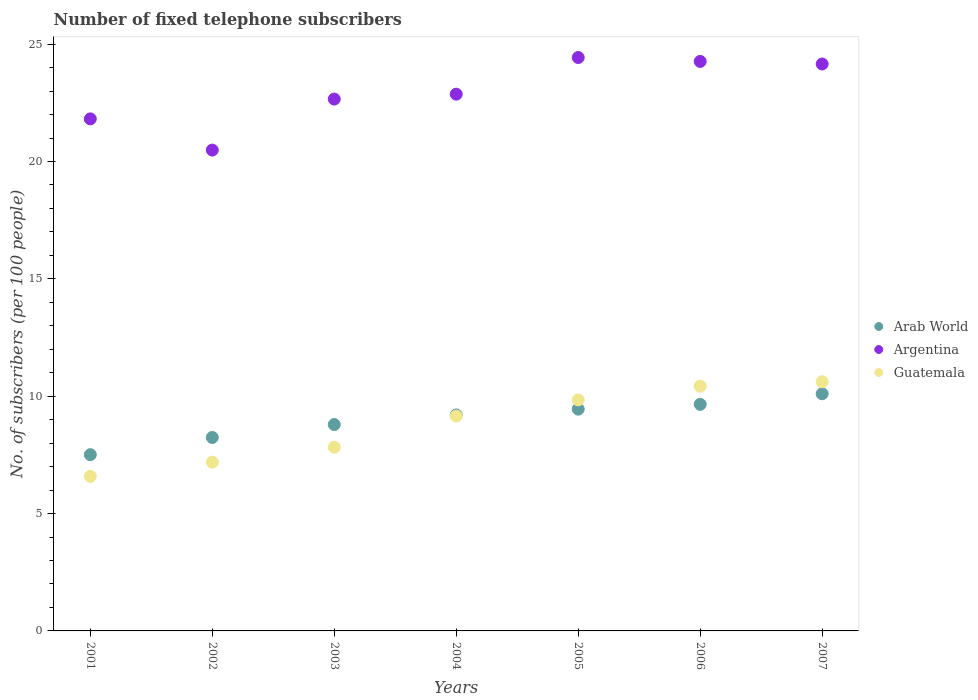What is the number of fixed telephone subscribers in Argentina in 2004?
Provide a short and direct response. 22.87. Across all years, what is the maximum number of fixed telephone subscribers in Argentina?
Make the answer very short. 24.43. Across all years, what is the minimum number of fixed telephone subscribers in Guatemala?
Your response must be concise. 6.59. In which year was the number of fixed telephone subscribers in Arab World maximum?
Your response must be concise. 2007. What is the total number of fixed telephone subscribers in Guatemala in the graph?
Ensure brevity in your answer.  61.64. What is the difference between the number of fixed telephone subscribers in Arab World in 2003 and that in 2006?
Make the answer very short. -0.86. What is the difference between the number of fixed telephone subscribers in Guatemala in 2006 and the number of fixed telephone subscribers in Arab World in 2002?
Your answer should be compact. 2.18. What is the average number of fixed telephone subscribers in Argentina per year?
Keep it short and to the point. 22.95. In the year 2001, what is the difference between the number of fixed telephone subscribers in Arab World and number of fixed telephone subscribers in Guatemala?
Your response must be concise. 0.92. What is the ratio of the number of fixed telephone subscribers in Arab World in 2005 to that in 2006?
Keep it short and to the point. 0.98. Is the number of fixed telephone subscribers in Guatemala in 2002 less than that in 2007?
Offer a terse response. Yes. What is the difference between the highest and the second highest number of fixed telephone subscribers in Guatemala?
Your answer should be very brief. 0.19. What is the difference between the highest and the lowest number of fixed telephone subscribers in Arab World?
Give a very brief answer. 2.6. Is the number of fixed telephone subscribers in Arab World strictly greater than the number of fixed telephone subscribers in Guatemala over the years?
Your response must be concise. No. What is the difference between two consecutive major ticks on the Y-axis?
Offer a very short reply. 5. Are the values on the major ticks of Y-axis written in scientific E-notation?
Offer a terse response. No. Does the graph contain any zero values?
Your answer should be very brief. No. Where does the legend appear in the graph?
Make the answer very short. Center right. How are the legend labels stacked?
Your response must be concise. Vertical. What is the title of the graph?
Your answer should be compact. Number of fixed telephone subscribers. What is the label or title of the X-axis?
Your answer should be very brief. Years. What is the label or title of the Y-axis?
Offer a very short reply. No. of subscribers (per 100 people). What is the No. of subscribers (per 100 people) in Arab World in 2001?
Ensure brevity in your answer.  7.51. What is the No. of subscribers (per 100 people) in Argentina in 2001?
Make the answer very short. 21.82. What is the No. of subscribers (per 100 people) of Guatemala in 2001?
Give a very brief answer. 6.59. What is the No. of subscribers (per 100 people) of Arab World in 2002?
Your answer should be very brief. 8.24. What is the No. of subscribers (per 100 people) in Argentina in 2002?
Provide a short and direct response. 20.49. What is the No. of subscribers (per 100 people) in Guatemala in 2002?
Offer a very short reply. 7.19. What is the No. of subscribers (per 100 people) of Arab World in 2003?
Provide a succinct answer. 8.79. What is the No. of subscribers (per 100 people) in Argentina in 2003?
Give a very brief answer. 22.66. What is the No. of subscribers (per 100 people) of Guatemala in 2003?
Offer a very short reply. 7.83. What is the No. of subscribers (per 100 people) of Arab World in 2004?
Provide a short and direct response. 9.2. What is the No. of subscribers (per 100 people) of Argentina in 2004?
Offer a very short reply. 22.87. What is the No. of subscribers (per 100 people) in Guatemala in 2004?
Offer a terse response. 9.15. What is the No. of subscribers (per 100 people) in Arab World in 2005?
Give a very brief answer. 9.45. What is the No. of subscribers (per 100 people) in Argentina in 2005?
Your answer should be compact. 24.43. What is the No. of subscribers (per 100 people) in Guatemala in 2005?
Ensure brevity in your answer.  9.84. What is the No. of subscribers (per 100 people) of Arab World in 2006?
Provide a short and direct response. 9.65. What is the No. of subscribers (per 100 people) in Argentina in 2006?
Your answer should be very brief. 24.26. What is the No. of subscribers (per 100 people) of Guatemala in 2006?
Provide a short and direct response. 10.43. What is the No. of subscribers (per 100 people) in Arab World in 2007?
Your answer should be compact. 10.1. What is the No. of subscribers (per 100 people) of Argentina in 2007?
Your answer should be compact. 24.15. What is the No. of subscribers (per 100 people) in Guatemala in 2007?
Provide a short and direct response. 10.61. Across all years, what is the maximum No. of subscribers (per 100 people) in Arab World?
Offer a terse response. 10.1. Across all years, what is the maximum No. of subscribers (per 100 people) of Argentina?
Give a very brief answer. 24.43. Across all years, what is the maximum No. of subscribers (per 100 people) in Guatemala?
Provide a short and direct response. 10.61. Across all years, what is the minimum No. of subscribers (per 100 people) of Arab World?
Make the answer very short. 7.51. Across all years, what is the minimum No. of subscribers (per 100 people) of Argentina?
Your answer should be very brief. 20.49. Across all years, what is the minimum No. of subscribers (per 100 people) of Guatemala?
Provide a short and direct response. 6.59. What is the total No. of subscribers (per 100 people) of Arab World in the graph?
Your answer should be very brief. 62.95. What is the total No. of subscribers (per 100 people) of Argentina in the graph?
Offer a terse response. 160.68. What is the total No. of subscribers (per 100 people) of Guatemala in the graph?
Keep it short and to the point. 61.64. What is the difference between the No. of subscribers (per 100 people) in Arab World in 2001 and that in 2002?
Keep it short and to the point. -0.73. What is the difference between the No. of subscribers (per 100 people) in Argentina in 2001 and that in 2002?
Make the answer very short. 1.33. What is the difference between the No. of subscribers (per 100 people) of Guatemala in 2001 and that in 2002?
Provide a succinct answer. -0.6. What is the difference between the No. of subscribers (per 100 people) of Arab World in 2001 and that in 2003?
Give a very brief answer. -1.28. What is the difference between the No. of subscribers (per 100 people) in Argentina in 2001 and that in 2003?
Offer a very short reply. -0.84. What is the difference between the No. of subscribers (per 100 people) in Guatemala in 2001 and that in 2003?
Give a very brief answer. -1.24. What is the difference between the No. of subscribers (per 100 people) in Arab World in 2001 and that in 2004?
Make the answer very short. -1.69. What is the difference between the No. of subscribers (per 100 people) of Argentina in 2001 and that in 2004?
Ensure brevity in your answer.  -1.05. What is the difference between the No. of subscribers (per 100 people) in Guatemala in 2001 and that in 2004?
Make the answer very short. -2.57. What is the difference between the No. of subscribers (per 100 people) in Arab World in 2001 and that in 2005?
Provide a succinct answer. -1.94. What is the difference between the No. of subscribers (per 100 people) of Argentina in 2001 and that in 2005?
Provide a succinct answer. -2.61. What is the difference between the No. of subscribers (per 100 people) of Guatemala in 2001 and that in 2005?
Ensure brevity in your answer.  -3.26. What is the difference between the No. of subscribers (per 100 people) in Arab World in 2001 and that in 2006?
Give a very brief answer. -2.14. What is the difference between the No. of subscribers (per 100 people) in Argentina in 2001 and that in 2006?
Provide a short and direct response. -2.45. What is the difference between the No. of subscribers (per 100 people) in Guatemala in 2001 and that in 2006?
Give a very brief answer. -3.84. What is the difference between the No. of subscribers (per 100 people) in Arab World in 2001 and that in 2007?
Make the answer very short. -2.6. What is the difference between the No. of subscribers (per 100 people) in Argentina in 2001 and that in 2007?
Offer a terse response. -2.34. What is the difference between the No. of subscribers (per 100 people) in Guatemala in 2001 and that in 2007?
Ensure brevity in your answer.  -4.03. What is the difference between the No. of subscribers (per 100 people) in Arab World in 2002 and that in 2003?
Your response must be concise. -0.55. What is the difference between the No. of subscribers (per 100 people) in Argentina in 2002 and that in 2003?
Ensure brevity in your answer.  -2.17. What is the difference between the No. of subscribers (per 100 people) of Guatemala in 2002 and that in 2003?
Your answer should be compact. -0.64. What is the difference between the No. of subscribers (per 100 people) of Arab World in 2002 and that in 2004?
Your answer should be very brief. -0.96. What is the difference between the No. of subscribers (per 100 people) in Argentina in 2002 and that in 2004?
Your answer should be compact. -2.38. What is the difference between the No. of subscribers (per 100 people) in Guatemala in 2002 and that in 2004?
Keep it short and to the point. -1.96. What is the difference between the No. of subscribers (per 100 people) in Arab World in 2002 and that in 2005?
Your answer should be very brief. -1.21. What is the difference between the No. of subscribers (per 100 people) in Argentina in 2002 and that in 2005?
Ensure brevity in your answer.  -3.94. What is the difference between the No. of subscribers (per 100 people) of Guatemala in 2002 and that in 2005?
Ensure brevity in your answer.  -2.65. What is the difference between the No. of subscribers (per 100 people) of Arab World in 2002 and that in 2006?
Give a very brief answer. -1.41. What is the difference between the No. of subscribers (per 100 people) in Argentina in 2002 and that in 2006?
Ensure brevity in your answer.  -3.78. What is the difference between the No. of subscribers (per 100 people) of Guatemala in 2002 and that in 2006?
Ensure brevity in your answer.  -3.24. What is the difference between the No. of subscribers (per 100 people) in Arab World in 2002 and that in 2007?
Provide a succinct answer. -1.86. What is the difference between the No. of subscribers (per 100 people) in Argentina in 2002 and that in 2007?
Make the answer very short. -3.67. What is the difference between the No. of subscribers (per 100 people) in Guatemala in 2002 and that in 2007?
Ensure brevity in your answer.  -3.42. What is the difference between the No. of subscribers (per 100 people) in Arab World in 2003 and that in 2004?
Keep it short and to the point. -0.41. What is the difference between the No. of subscribers (per 100 people) in Argentina in 2003 and that in 2004?
Make the answer very short. -0.21. What is the difference between the No. of subscribers (per 100 people) of Guatemala in 2003 and that in 2004?
Provide a succinct answer. -1.33. What is the difference between the No. of subscribers (per 100 people) of Arab World in 2003 and that in 2005?
Offer a terse response. -0.65. What is the difference between the No. of subscribers (per 100 people) in Argentina in 2003 and that in 2005?
Your answer should be very brief. -1.77. What is the difference between the No. of subscribers (per 100 people) in Guatemala in 2003 and that in 2005?
Offer a terse response. -2.02. What is the difference between the No. of subscribers (per 100 people) in Arab World in 2003 and that in 2006?
Give a very brief answer. -0.86. What is the difference between the No. of subscribers (per 100 people) in Argentina in 2003 and that in 2006?
Your answer should be compact. -1.6. What is the difference between the No. of subscribers (per 100 people) in Guatemala in 2003 and that in 2006?
Provide a short and direct response. -2.6. What is the difference between the No. of subscribers (per 100 people) of Arab World in 2003 and that in 2007?
Provide a short and direct response. -1.31. What is the difference between the No. of subscribers (per 100 people) in Argentina in 2003 and that in 2007?
Offer a terse response. -1.49. What is the difference between the No. of subscribers (per 100 people) of Guatemala in 2003 and that in 2007?
Offer a terse response. -2.79. What is the difference between the No. of subscribers (per 100 people) in Arab World in 2004 and that in 2005?
Your response must be concise. -0.25. What is the difference between the No. of subscribers (per 100 people) in Argentina in 2004 and that in 2005?
Keep it short and to the point. -1.56. What is the difference between the No. of subscribers (per 100 people) of Guatemala in 2004 and that in 2005?
Your response must be concise. -0.69. What is the difference between the No. of subscribers (per 100 people) of Arab World in 2004 and that in 2006?
Your response must be concise. -0.45. What is the difference between the No. of subscribers (per 100 people) in Argentina in 2004 and that in 2006?
Provide a short and direct response. -1.39. What is the difference between the No. of subscribers (per 100 people) in Guatemala in 2004 and that in 2006?
Offer a terse response. -1.27. What is the difference between the No. of subscribers (per 100 people) of Arab World in 2004 and that in 2007?
Your response must be concise. -0.9. What is the difference between the No. of subscribers (per 100 people) of Argentina in 2004 and that in 2007?
Make the answer very short. -1.29. What is the difference between the No. of subscribers (per 100 people) of Guatemala in 2004 and that in 2007?
Keep it short and to the point. -1.46. What is the difference between the No. of subscribers (per 100 people) of Arab World in 2005 and that in 2006?
Your response must be concise. -0.21. What is the difference between the No. of subscribers (per 100 people) of Argentina in 2005 and that in 2006?
Make the answer very short. 0.17. What is the difference between the No. of subscribers (per 100 people) in Guatemala in 2005 and that in 2006?
Keep it short and to the point. -0.58. What is the difference between the No. of subscribers (per 100 people) in Arab World in 2005 and that in 2007?
Your answer should be compact. -0.66. What is the difference between the No. of subscribers (per 100 people) in Argentina in 2005 and that in 2007?
Make the answer very short. 0.28. What is the difference between the No. of subscribers (per 100 people) in Guatemala in 2005 and that in 2007?
Provide a short and direct response. -0.77. What is the difference between the No. of subscribers (per 100 people) of Arab World in 2006 and that in 2007?
Keep it short and to the point. -0.45. What is the difference between the No. of subscribers (per 100 people) in Argentina in 2006 and that in 2007?
Offer a terse response. 0.11. What is the difference between the No. of subscribers (per 100 people) of Guatemala in 2006 and that in 2007?
Your answer should be very brief. -0.19. What is the difference between the No. of subscribers (per 100 people) of Arab World in 2001 and the No. of subscribers (per 100 people) of Argentina in 2002?
Ensure brevity in your answer.  -12.98. What is the difference between the No. of subscribers (per 100 people) of Arab World in 2001 and the No. of subscribers (per 100 people) of Guatemala in 2002?
Provide a short and direct response. 0.32. What is the difference between the No. of subscribers (per 100 people) of Argentina in 2001 and the No. of subscribers (per 100 people) of Guatemala in 2002?
Your answer should be compact. 14.63. What is the difference between the No. of subscribers (per 100 people) in Arab World in 2001 and the No. of subscribers (per 100 people) in Argentina in 2003?
Your answer should be very brief. -15.15. What is the difference between the No. of subscribers (per 100 people) of Arab World in 2001 and the No. of subscribers (per 100 people) of Guatemala in 2003?
Offer a terse response. -0.32. What is the difference between the No. of subscribers (per 100 people) of Argentina in 2001 and the No. of subscribers (per 100 people) of Guatemala in 2003?
Offer a very short reply. 13.99. What is the difference between the No. of subscribers (per 100 people) of Arab World in 2001 and the No. of subscribers (per 100 people) of Argentina in 2004?
Your answer should be very brief. -15.36. What is the difference between the No. of subscribers (per 100 people) of Arab World in 2001 and the No. of subscribers (per 100 people) of Guatemala in 2004?
Keep it short and to the point. -1.64. What is the difference between the No. of subscribers (per 100 people) of Argentina in 2001 and the No. of subscribers (per 100 people) of Guatemala in 2004?
Offer a terse response. 12.66. What is the difference between the No. of subscribers (per 100 people) in Arab World in 2001 and the No. of subscribers (per 100 people) in Argentina in 2005?
Offer a very short reply. -16.92. What is the difference between the No. of subscribers (per 100 people) of Arab World in 2001 and the No. of subscribers (per 100 people) of Guatemala in 2005?
Keep it short and to the point. -2.34. What is the difference between the No. of subscribers (per 100 people) in Argentina in 2001 and the No. of subscribers (per 100 people) in Guatemala in 2005?
Provide a succinct answer. 11.97. What is the difference between the No. of subscribers (per 100 people) in Arab World in 2001 and the No. of subscribers (per 100 people) in Argentina in 2006?
Your response must be concise. -16.75. What is the difference between the No. of subscribers (per 100 people) in Arab World in 2001 and the No. of subscribers (per 100 people) in Guatemala in 2006?
Your answer should be compact. -2.92. What is the difference between the No. of subscribers (per 100 people) of Argentina in 2001 and the No. of subscribers (per 100 people) of Guatemala in 2006?
Your answer should be very brief. 11.39. What is the difference between the No. of subscribers (per 100 people) in Arab World in 2001 and the No. of subscribers (per 100 people) in Argentina in 2007?
Make the answer very short. -16.64. What is the difference between the No. of subscribers (per 100 people) of Arab World in 2001 and the No. of subscribers (per 100 people) of Guatemala in 2007?
Offer a very short reply. -3.11. What is the difference between the No. of subscribers (per 100 people) of Argentina in 2001 and the No. of subscribers (per 100 people) of Guatemala in 2007?
Offer a terse response. 11.2. What is the difference between the No. of subscribers (per 100 people) of Arab World in 2002 and the No. of subscribers (per 100 people) of Argentina in 2003?
Make the answer very short. -14.42. What is the difference between the No. of subscribers (per 100 people) in Arab World in 2002 and the No. of subscribers (per 100 people) in Guatemala in 2003?
Your answer should be compact. 0.42. What is the difference between the No. of subscribers (per 100 people) of Argentina in 2002 and the No. of subscribers (per 100 people) of Guatemala in 2003?
Your response must be concise. 12.66. What is the difference between the No. of subscribers (per 100 people) in Arab World in 2002 and the No. of subscribers (per 100 people) in Argentina in 2004?
Your response must be concise. -14.63. What is the difference between the No. of subscribers (per 100 people) of Arab World in 2002 and the No. of subscribers (per 100 people) of Guatemala in 2004?
Offer a terse response. -0.91. What is the difference between the No. of subscribers (per 100 people) in Argentina in 2002 and the No. of subscribers (per 100 people) in Guatemala in 2004?
Your response must be concise. 11.33. What is the difference between the No. of subscribers (per 100 people) in Arab World in 2002 and the No. of subscribers (per 100 people) in Argentina in 2005?
Provide a succinct answer. -16.19. What is the difference between the No. of subscribers (per 100 people) of Arab World in 2002 and the No. of subscribers (per 100 people) of Guatemala in 2005?
Your response must be concise. -1.6. What is the difference between the No. of subscribers (per 100 people) of Argentina in 2002 and the No. of subscribers (per 100 people) of Guatemala in 2005?
Give a very brief answer. 10.64. What is the difference between the No. of subscribers (per 100 people) in Arab World in 2002 and the No. of subscribers (per 100 people) in Argentina in 2006?
Your answer should be very brief. -16.02. What is the difference between the No. of subscribers (per 100 people) of Arab World in 2002 and the No. of subscribers (per 100 people) of Guatemala in 2006?
Offer a terse response. -2.18. What is the difference between the No. of subscribers (per 100 people) of Argentina in 2002 and the No. of subscribers (per 100 people) of Guatemala in 2006?
Provide a succinct answer. 10.06. What is the difference between the No. of subscribers (per 100 people) of Arab World in 2002 and the No. of subscribers (per 100 people) of Argentina in 2007?
Provide a succinct answer. -15.91. What is the difference between the No. of subscribers (per 100 people) in Arab World in 2002 and the No. of subscribers (per 100 people) in Guatemala in 2007?
Give a very brief answer. -2.37. What is the difference between the No. of subscribers (per 100 people) of Argentina in 2002 and the No. of subscribers (per 100 people) of Guatemala in 2007?
Your answer should be very brief. 9.87. What is the difference between the No. of subscribers (per 100 people) in Arab World in 2003 and the No. of subscribers (per 100 people) in Argentina in 2004?
Offer a very short reply. -14.07. What is the difference between the No. of subscribers (per 100 people) in Arab World in 2003 and the No. of subscribers (per 100 people) in Guatemala in 2004?
Provide a short and direct response. -0.36. What is the difference between the No. of subscribers (per 100 people) in Argentina in 2003 and the No. of subscribers (per 100 people) in Guatemala in 2004?
Make the answer very short. 13.51. What is the difference between the No. of subscribers (per 100 people) of Arab World in 2003 and the No. of subscribers (per 100 people) of Argentina in 2005?
Give a very brief answer. -15.64. What is the difference between the No. of subscribers (per 100 people) of Arab World in 2003 and the No. of subscribers (per 100 people) of Guatemala in 2005?
Your answer should be compact. -1.05. What is the difference between the No. of subscribers (per 100 people) in Argentina in 2003 and the No. of subscribers (per 100 people) in Guatemala in 2005?
Your response must be concise. 12.81. What is the difference between the No. of subscribers (per 100 people) of Arab World in 2003 and the No. of subscribers (per 100 people) of Argentina in 2006?
Your answer should be very brief. -15.47. What is the difference between the No. of subscribers (per 100 people) in Arab World in 2003 and the No. of subscribers (per 100 people) in Guatemala in 2006?
Provide a succinct answer. -1.63. What is the difference between the No. of subscribers (per 100 people) in Argentina in 2003 and the No. of subscribers (per 100 people) in Guatemala in 2006?
Your answer should be very brief. 12.23. What is the difference between the No. of subscribers (per 100 people) of Arab World in 2003 and the No. of subscribers (per 100 people) of Argentina in 2007?
Give a very brief answer. -15.36. What is the difference between the No. of subscribers (per 100 people) of Arab World in 2003 and the No. of subscribers (per 100 people) of Guatemala in 2007?
Your answer should be compact. -1.82. What is the difference between the No. of subscribers (per 100 people) of Argentina in 2003 and the No. of subscribers (per 100 people) of Guatemala in 2007?
Give a very brief answer. 12.04. What is the difference between the No. of subscribers (per 100 people) in Arab World in 2004 and the No. of subscribers (per 100 people) in Argentina in 2005?
Give a very brief answer. -15.23. What is the difference between the No. of subscribers (per 100 people) of Arab World in 2004 and the No. of subscribers (per 100 people) of Guatemala in 2005?
Make the answer very short. -0.64. What is the difference between the No. of subscribers (per 100 people) in Argentina in 2004 and the No. of subscribers (per 100 people) in Guatemala in 2005?
Ensure brevity in your answer.  13.02. What is the difference between the No. of subscribers (per 100 people) of Arab World in 2004 and the No. of subscribers (per 100 people) of Argentina in 2006?
Provide a succinct answer. -15.06. What is the difference between the No. of subscribers (per 100 people) in Arab World in 2004 and the No. of subscribers (per 100 people) in Guatemala in 2006?
Provide a short and direct response. -1.22. What is the difference between the No. of subscribers (per 100 people) in Argentina in 2004 and the No. of subscribers (per 100 people) in Guatemala in 2006?
Provide a short and direct response. 12.44. What is the difference between the No. of subscribers (per 100 people) in Arab World in 2004 and the No. of subscribers (per 100 people) in Argentina in 2007?
Provide a succinct answer. -14.95. What is the difference between the No. of subscribers (per 100 people) in Arab World in 2004 and the No. of subscribers (per 100 people) in Guatemala in 2007?
Provide a succinct answer. -1.41. What is the difference between the No. of subscribers (per 100 people) of Argentina in 2004 and the No. of subscribers (per 100 people) of Guatemala in 2007?
Provide a succinct answer. 12.25. What is the difference between the No. of subscribers (per 100 people) of Arab World in 2005 and the No. of subscribers (per 100 people) of Argentina in 2006?
Offer a very short reply. -14.81. What is the difference between the No. of subscribers (per 100 people) of Arab World in 2005 and the No. of subscribers (per 100 people) of Guatemala in 2006?
Offer a terse response. -0.98. What is the difference between the No. of subscribers (per 100 people) in Argentina in 2005 and the No. of subscribers (per 100 people) in Guatemala in 2006?
Offer a terse response. 14. What is the difference between the No. of subscribers (per 100 people) in Arab World in 2005 and the No. of subscribers (per 100 people) in Argentina in 2007?
Give a very brief answer. -14.71. What is the difference between the No. of subscribers (per 100 people) of Arab World in 2005 and the No. of subscribers (per 100 people) of Guatemala in 2007?
Ensure brevity in your answer.  -1.17. What is the difference between the No. of subscribers (per 100 people) in Argentina in 2005 and the No. of subscribers (per 100 people) in Guatemala in 2007?
Provide a succinct answer. 13.81. What is the difference between the No. of subscribers (per 100 people) in Arab World in 2006 and the No. of subscribers (per 100 people) in Argentina in 2007?
Provide a short and direct response. -14.5. What is the difference between the No. of subscribers (per 100 people) of Arab World in 2006 and the No. of subscribers (per 100 people) of Guatemala in 2007?
Give a very brief answer. -0.96. What is the difference between the No. of subscribers (per 100 people) of Argentina in 2006 and the No. of subscribers (per 100 people) of Guatemala in 2007?
Offer a terse response. 13.65. What is the average No. of subscribers (per 100 people) in Arab World per year?
Keep it short and to the point. 8.99. What is the average No. of subscribers (per 100 people) of Argentina per year?
Your response must be concise. 22.95. What is the average No. of subscribers (per 100 people) of Guatemala per year?
Your answer should be very brief. 8.81. In the year 2001, what is the difference between the No. of subscribers (per 100 people) in Arab World and No. of subscribers (per 100 people) in Argentina?
Your answer should be compact. -14.31. In the year 2001, what is the difference between the No. of subscribers (per 100 people) of Arab World and No. of subscribers (per 100 people) of Guatemala?
Your answer should be very brief. 0.92. In the year 2001, what is the difference between the No. of subscribers (per 100 people) in Argentina and No. of subscribers (per 100 people) in Guatemala?
Offer a terse response. 15.23. In the year 2002, what is the difference between the No. of subscribers (per 100 people) of Arab World and No. of subscribers (per 100 people) of Argentina?
Keep it short and to the point. -12.24. In the year 2002, what is the difference between the No. of subscribers (per 100 people) of Arab World and No. of subscribers (per 100 people) of Guatemala?
Keep it short and to the point. 1.05. In the year 2002, what is the difference between the No. of subscribers (per 100 people) of Argentina and No. of subscribers (per 100 people) of Guatemala?
Offer a terse response. 13.3. In the year 2003, what is the difference between the No. of subscribers (per 100 people) of Arab World and No. of subscribers (per 100 people) of Argentina?
Offer a very short reply. -13.87. In the year 2003, what is the difference between the No. of subscribers (per 100 people) of Arab World and No. of subscribers (per 100 people) of Guatemala?
Provide a succinct answer. 0.97. In the year 2003, what is the difference between the No. of subscribers (per 100 people) in Argentina and No. of subscribers (per 100 people) in Guatemala?
Provide a succinct answer. 14.83. In the year 2004, what is the difference between the No. of subscribers (per 100 people) of Arab World and No. of subscribers (per 100 people) of Argentina?
Your response must be concise. -13.67. In the year 2004, what is the difference between the No. of subscribers (per 100 people) in Arab World and No. of subscribers (per 100 people) in Guatemala?
Provide a short and direct response. 0.05. In the year 2004, what is the difference between the No. of subscribers (per 100 people) of Argentina and No. of subscribers (per 100 people) of Guatemala?
Keep it short and to the point. 13.71. In the year 2005, what is the difference between the No. of subscribers (per 100 people) of Arab World and No. of subscribers (per 100 people) of Argentina?
Your answer should be very brief. -14.98. In the year 2005, what is the difference between the No. of subscribers (per 100 people) of Arab World and No. of subscribers (per 100 people) of Guatemala?
Keep it short and to the point. -0.4. In the year 2005, what is the difference between the No. of subscribers (per 100 people) of Argentina and No. of subscribers (per 100 people) of Guatemala?
Give a very brief answer. 14.59. In the year 2006, what is the difference between the No. of subscribers (per 100 people) of Arab World and No. of subscribers (per 100 people) of Argentina?
Provide a succinct answer. -14.61. In the year 2006, what is the difference between the No. of subscribers (per 100 people) in Arab World and No. of subscribers (per 100 people) in Guatemala?
Give a very brief answer. -0.77. In the year 2006, what is the difference between the No. of subscribers (per 100 people) in Argentina and No. of subscribers (per 100 people) in Guatemala?
Provide a short and direct response. 13.84. In the year 2007, what is the difference between the No. of subscribers (per 100 people) of Arab World and No. of subscribers (per 100 people) of Argentina?
Your answer should be very brief. -14.05. In the year 2007, what is the difference between the No. of subscribers (per 100 people) in Arab World and No. of subscribers (per 100 people) in Guatemala?
Ensure brevity in your answer.  -0.51. In the year 2007, what is the difference between the No. of subscribers (per 100 people) of Argentina and No. of subscribers (per 100 people) of Guatemala?
Make the answer very short. 13.54. What is the ratio of the No. of subscribers (per 100 people) of Arab World in 2001 to that in 2002?
Give a very brief answer. 0.91. What is the ratio of the No. of subscribers (per 100 people) of Argentina in 2001 to that in 2002?
Ensure brevity in your answer.  1.06. What is the ratio of the No. of subscribers (per 100 people) of Guatemala in 2001 to that in 2002?
Ensure brevity in your answer.  0.92. What is the ratio of the No. of subscribers (per 100 people) in Arab World in 2001 to that in 2003?
Your answer should be very brief. 0.85. What is the ratio of the No. of subscribers (per 100 people) in Argentina in 2001 to that in 2003?
Your answer should be very brief. 0.96. What is the ratio of the No. of subscribers (per 100 people) of Guatemala in 2001 to that in 2003?
Your answer should be very brief. 0.84. What is the ratio of the No. of subscribers (per 100 people) of Arab World in 2001 to that in 2004?
Ensure brevity in your answer.  0.82. What is the ratio of the No. of subscribers (per 100 people) of Argentina in 2001 to that in 2004?
Offer a terse response. 0.95. What is the ratio of the No. of subscribers (per 100 people) in Guatemala in 2001 to that in 2004?
Offer a very short reply. 0.72. What is the ratio of the No. of subscribers (per 100 people) of Arab World in 2001 to that in 2005?
Offer a very short reply. 0.79. What is the ratio of the No. of subscribers (per 100 people) in Argentina in 2001 to that in 2005?
Make the answer very short. 0.89. What is the ratio of the No. of subscribers (per 100 people) of Guatemala in 2001 to that in 2005?
Ensure brevity in your answer.  0.67. What is the ratio of the No. of subscribers (per 100 people) of Argentina in 2001 to that in 2006?
Ensure brevity in your answer.  0.9. What is the ratio of the No. of subscribers (per 100 people) of Guatemala in 2001 to that in 2006?
Ensure brevity in your answer.  0.63. What is the ratio of the No. of subscribers (per 100 people) of Arab World in 2001 to that in 2007?
Your response must be concise. 0.74. What is the ratio of the No. of subscribers (per 100 people) of Argentina in 2001 to that in 2007?
Provide a short and direct response. 0.9. What is the ratio of the No. of subscribers (per 100 people) in Guatemala in 2001 to that in 2007?
Your answer should be compact. 0.62. What is the ratio of the No. of subscribers (per 100 people) in Arab World in 2002 to that in 2003?
Your answer should be compact. 0.94. What is the ratio of the No. of subscribers (per 100 people) in Argentina in 2002 to that in 2003?
Provide a succinct answer. 0.9. What is the ratio of the No. of subscribers (per 100 people) of Guatemala in 2002 to that in 2003?
Offer a terse response. 0.92. What is the ratio of the No. of subscribers (per 100 people) in Arab World in 2002 to that in 2004?
Give a very brief answer. 0.9. What is the ratio of the No. of subscribers (per 100 people) in Argentina in 2002 to that in 2004?
Your answer should be very brief. 0.9. What is the ratio of the No. of subscribers (per 100 people) in Guatemala in 2002 to that in 2004?
Offer a very short reply. 0.79. What is the ratio of the No. of subscribers (per 100 people) of Arab World in 2002 to that in 2005?
Your answer should be compact. 0.87. What is the ratio of the No. of subscribers (per 100 people) of Argentina in 2002 to that in 2005?
Offer a terse response. 0.84. What is the ratio of the No. of subscribers (per 100 people) in Guatemala in 2002 to that in 2005?
Your answer should be compact. 0.73. What is the ratio of the No. of subscribers (per 100 people) in Arab World in 2002 to that in 2006?
Provide a succinct answer. 0.85. What is the ratio of the No. of subscribers (per 100 people) of Argentina in 2002 to that in 2006?
Your answer should be compact. 0.84. What is the ratio of the No. of subscribers (per 100 people) in Guatemala in 2002 to that in 2006?
Provide a succinct answer. 0.69. What is the ratio of the No. of subscribers (per 100 people) in Arab World in 2002 to that in 2007?
Your response must be concise. 0.82. What is the ratio of the No. of subscribers (per 100 people) of Argentina in 2002 to that in 2007?
Your response must be concise. 0.85. What is the ratio of the No. of subscribers (per 100 people) in Guatemala in 2002 to that in 2007?
Give a very brief answer. 0.68. What is the ratio of the No. of subscribers (per 100 people) in Arab World in 2003 to that in 2004?
Your answer should be compact. 0.96. What is the ratio of the No. of subscribers (per 100 people) in Argentina in 2003 to that in 2004?
Offer a very short reply. 0.99. What is the ratio of the No. of subscribers (per 100 people) in Guatemala in 2003 to that in 2004?
Provide a short and direct response. 0.85. What is the ratio of the No. of subscribers (per 100 people) in Arab World in 2003 to that in 2005?
Keep it short and to the point. 0.93. What is the ratio of the No. of subscribers (per 100 people) in Argentina in 2003 to that in 2005?
Offer a very short reply. 0.93. What is the ratio of the No. of subscribers (per 100 people) in Guatemala in 2003 to that in 2005?
Your answer should be very brief. 0.8. What is the ratio of the No. of subscribers (per 100 people) in Arab World in 2003 to that in 2006?
Offer a terse response. 0.91. What is the ratio of the No. of subscribers (per 100 people) of Argentina in 2003 to that in 2006?
Offer a terse response. 0.93. What is the ratio of the No. of subscribers (per 100 people) of Guatemala in 2003 to that in 2006?
Offer a terse response. 0.75. What is the ratio of the No. of subscribers (per 100 people) of Arab World in 2003 to that in 2007?
Offer a terse response. 0.87. What is the ratio of the No. of subscribers (per 100 people) of Argentina in 2003 to that in 2007?
Offer a very short reply. 0.94. What is the ratio of the No. of subscribers (per 100 people) of Guatemala in 2003 to that in 2007?
Offer a very short reply. 0.74. What is the ratio of the No. of subscribers (per 100 people) in Arab World in 2004 to that in 2005?
Ensure brevity in your answer.  0.97. What is the ratio of the No. of subscribers (per 100 people) in Argentina in 2004 to that in 2005?
Your response must be concise. 0.94. What is the ratio of the No. of subscribers (per 100 people) of Guatemala in 2004 to that in 2005?
Keep it short and to the point. 0.93. What is the ratio of the No. of subscribers (per 100 people) of Arab World in 2004 to that in 2006?
Your answer should be very brief. 0.95. What is the ratio of the No. of subscribers (per 100 people) of Argentina in 2004 to that in 2006?
Provide a succinct answer. 0.94. What is the ratio of the No. of subscribers (per 100 people) of Guatemala in 2004 to that in 2006?
Your answer should be very brief. 0.88. What is the ratio of the No. of subscribers (per 100 people) of Arab World in 2004 to that in 2007?
Make the answer very short. 0.91. What is the ratio of the No. of subscribers (per 100 people) in Argentina in 2004 to that in 2007?
Your answer should be very brief. 0.95. What is the ratio of the No. of subscribers (per 100 people) of Guatemala in 2004 to that in 2007?
Provide a short and direct response. 0.86. What is the ratio of the No. of subscribers (per 100 people) of Arab World in 2005 to that in 2006?
Offer a very short reply. 0.98. What is the ratio of the No. of subscribers (per 100 people) in Guatemala in 2005 to that in 2006?
Make the answer very short. 0.94. What is the ratio of the No. of subscribers (per 100 people) of Arab World in 2005 to that in 2007?
Offer a terse response. 0.94. What is the ratio of the No. of subscribers (per 100 people) of Argentina in 2005 to that in 2007?
Keep it short and to the point. 1.01. What is the ratio of the No. of subscribers (per 100 people) in Guatemala in 2005 to that in 2007?
Keep it short and to the point. 0.93. What is the ratio of the No. of subscribers (per 100 people) in Arab World in 2006 to that in 2007?
Provide a short and direct response. 0.96. What is the ratio of the No. of subscribers (per 100 people) of Guatemala in 2006 to that in 2007?
Provide a succinct answer. 0.98. What is the difference between the highest and the second highest No. of subscribers (per 100 people) of Arab World?
Offer a terse response. 0.45. What is the difference between the highest and the second highest No. of subscribers (per 100 people) of Argentina?
Keep it short and to the point. 0.17. What is the difference between the highest and the second highest No. of subscribers (per 100 people) in Guatemala?
Offer a terse response. 0.19. What is the difference between the highest and the lowest No. of subscribers (per 100 people) of Arab World?
Your answer should be very brief. 2.6. What is the difference between the highest and the lowest No. of subscribers (per 100 people) in Argentina?
Give a very brief answer. 3.94. What is the difference between the highest and the lowest No. of subscribers (per 100 people) in Guatemala?
Your answer should be very brief. 4.03. 